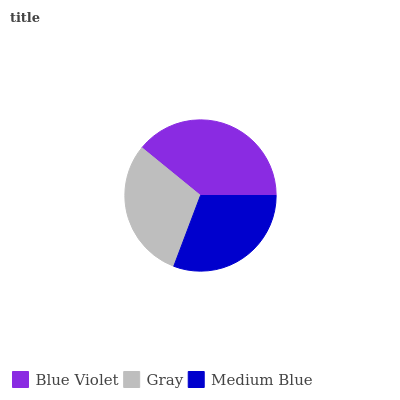Is Gray the minimum?
Answer yes or no. Yes. Is Blue Violet the maximum?
Answer yes or no. Yes. Is Medium Blue the minimum?
Answer yes or no. No. Is Medium Blue the maximum?
Answer yes or no. No. Is Medium Blue greater than Gray?
Answer yes or no. Yes. Is Gray less than Medium Blue?
Answer yes or no. Yes. Is Gray greater than Medium Blue?
Answer yes or no. No. Is Medium Blue less than Gray?
Answer yes or no. No. Is Medium Blue the high median?
Answer yes or no. Yes. Is Medium Blue the low median?
Answer yes or no. Yes. Is Gray the high median?
Answer yes or no. No. Is Blue Violet the low median?
Answer yes or no. No. 